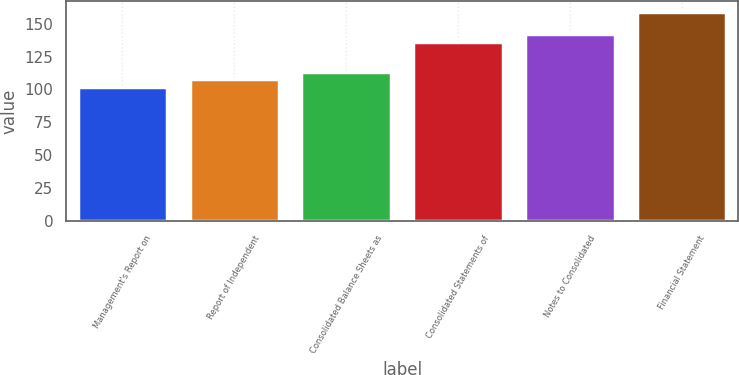Convert chart. <chart><loc_0><loc_0><loc_500><loc_500><bar_chart><fcel>Management's Report on<fcel>Report of Independent<fcel>Consolidated Balance Sheets as<fcel>Consolidated Statements of<fcel>Notes to Consolidated<fcel>Financial Statement<nl><fcel>102<fcel>107.7<fcel>113.4<fcel>136.2<fcel>141.9<fcel>159<nl></chart> 